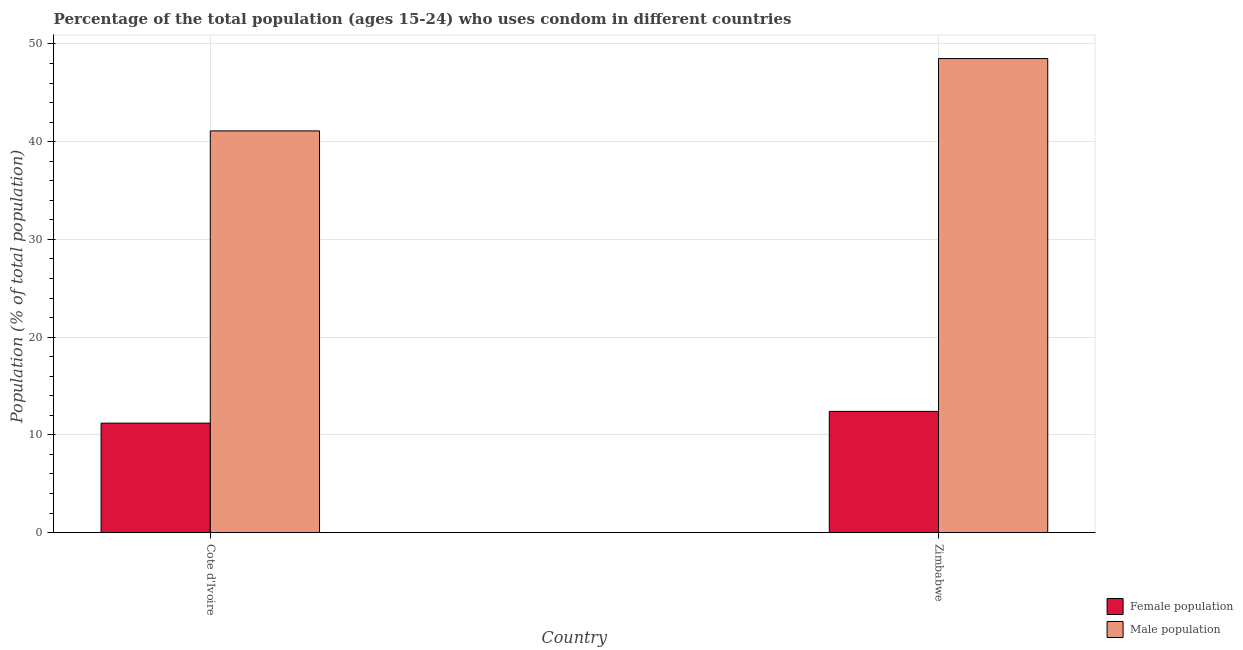How many different coloured bars are there?
Offer a terse response. 2. How many groups of bars are there?
Keep it short and to the point. 2. How many bars are there on the 1st tick from the right?
Give a very brief answer. 2. What is the label of the 2nd group of bars from the left?
Your response must be concise. Zimbabwe. What is the female population in Cote d'Ivoire?
Provide a short and direct response. 11.2. Across all countries, what is the maximum male population?
Your response must be concise. 48.5. Across all countries, what is the minimum female population?
Offer a terse response. 11.2. In which country was the female population maximum?
Keep it short and to the point. Zimbabwe. In which country was the female population minimum?
Your answer should be very brief. Cote d'Ivoire. What is the total female population in the graph?
Give a very brief answer. 23.6. What is the difference between the male population in Cote d'Ivoire and that in Zimbabwe?
Offer a very short reply. -7.4. What is the difference between the male population in Zimbabwe and the female population in Cote d'Ivoire?
Offer a terse response. 37.3. What is the average male population per country?
Offer a terse response. 44.8. What is the difference between the female population and male population in Zimbabwe?
Your answer should be very brief. -36.1. What is the ratio of the female population in Cote d'Ivoire to that in Zimbabwe?
Your answer should be compact. 0.9. What does the 1st bar from the left in Cote d'Ivoire represents?
Give a very brief answer. Female population. What does the 2nd bar from the right in Zimbabwe represents?
Give a very brief answer. Female population. How many bars are there?
Provide a short and direct response. 4. How many countries are there in the graph?
Ensure brevity in your answer.  2. What is the difference between two consecutive major ticks on the Y-axis?
Keep it short and to the point. 10. Does the graph contain grids?
Provide a succinct answer. Yes. How are the legend labels stacked?
Give a very brief answer. Vertical. What is the title of the graph?
Your response must be concise. Percentage of the total population (ages 15-24) who uses condom in different countries. Does "Under-5(male)" appear as one of the legend labels in the graph?
Provide a succinct answer. No. What is the label or title of the X-axis?
Your answer should be very brief. Country. What is the label or title of the Y-axis?
Make the answer very short. Population (% of total population) . What is the Population (% of total population)  in Male population in Cote d'Ivoire?
Keep it short and to the point. 41.1. What is the Population (% of total population)  of Male population in Zimbabwe?
Provide a short and direct response. 48.5. Across all countries, what is the maximum Population (% of total population)  of Male population?
Your answer should be very brief. 48.5. Across all countries, what is the minimum Population (% of total population)  of Male population?
Make the answer very short. 41.1. What is the total Population (% of total population)  of Female population in the graph?
Ensure brevity in your answer.  23.6. What is the total Population (% of total population)  of Male population in the graph?
Provide a short and direct response. 89.6. What is the difference between the Population (% of total population)  in Female population in Cote d'Ivoire and that in Zimbabwe?
Provide a succinct answer. -1.2. What is the difference between the Population (% of total population)  in Female population in Cote d'Ivoire and the Population (% of total population)  in Male population in Zimbabwe?
Offer a terse response. -37.3. What is the average Population (% of total population)  in Male population per country?
Make the answer very short. 44.8. What is the difference between the Population (% of total population)  of Female population and Population (% of total population)  of Male population in Cote d'Ivoire?
Your response must be concise. -29.9. What is the difference between the Population (% of total population)  in Female population and Population (% of total population)  in Male population in Zimbabwe?
Provide a short and direct response. -36.1. What is the ratio of the Population (% of total population)  of Female population in Cote d'Ivoire to that in Zimbabwe?
Provide a succinct answer. 0.9. What is the ratio of the Population (% of total population)  in Male population in Cote d'Ivoire to that in Zimbabwe?
Make the answer very short. 0.85. What is the difference between the highest and the second highest Population (% of total population)  in Female population?
Provide a short and direct response. 1.2. What is the difference between the highest and the lowest Population (% of total population)  in Female population?
Make the answer very short. 1.2. 